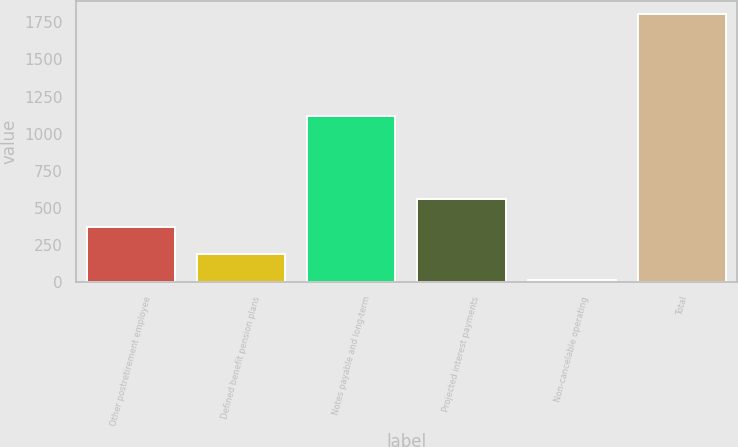<chart> <loc_0><loc_0><loc_500><loc_500><bar_chart><fcel>Other postretirement employee<fcel>Defined benefit pension plans<fcel>Notes payable and long-term<fcel>Projected interest payments<fcel>Non-cancelable operating<fcel>Total<nl><fcel>370.12<fcel>190.96<fcel>1121<fcel>561.9<fcel>11.8<fcel>1803.4<nl></chart> 